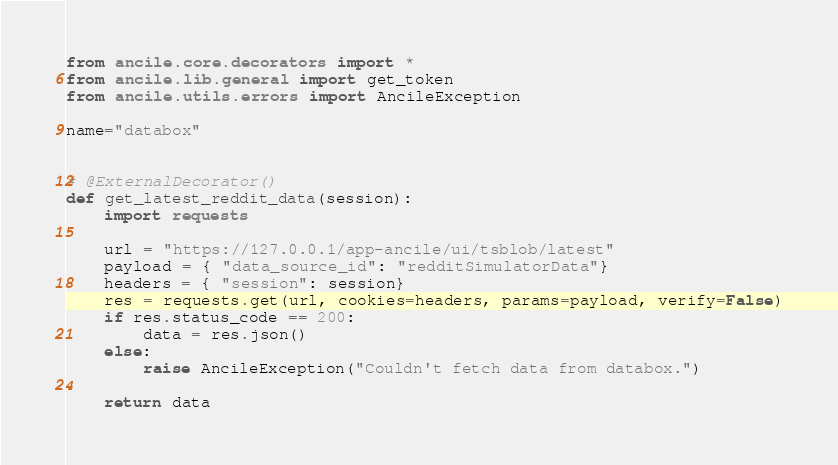<code> <loc_0><loc_0><loc_500><loc_500><_Python_>from ancile.core.decorators import *
from ancile.lib.general import get_token
from ancile.utils.errors import AncileException

name="databox"


# @ExternalDecorator()
def get_latest_reddit_data(session):
    import requests

    url = "https://127.0.0.1/app-ancile/ui/tsblob/latest"
    payload = { "data_source_id": "redditSimulatorData"}
    headers = { "session": session}
    res = requests.get(url, cookies=headers, params=payload, verify=False)
    if res.status_code == 200:
        data = res.json()
    else:
        raise AncileException("Couldn't fetch data from databox.")

    return data
</code> 